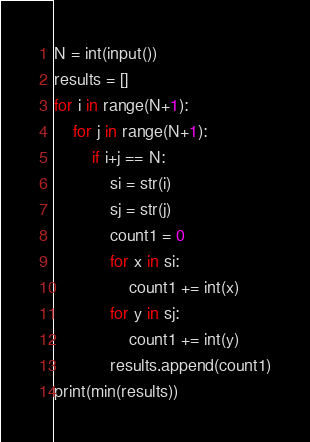Convert code to text. <code><loc_0><loc_0><loc_500><loc_500><_Python_>N = int(input())
results = []
for i in range(N+1):
    for j in range(N+1):
        if i+j == N:
            si = str(i)
            sj = str(j)
            count1 = 0
            for x in si:
                count1 += int(x)
            for y in sj:
                count1 += int(y)
            results.append(count1)
print(min(results))
</code> 